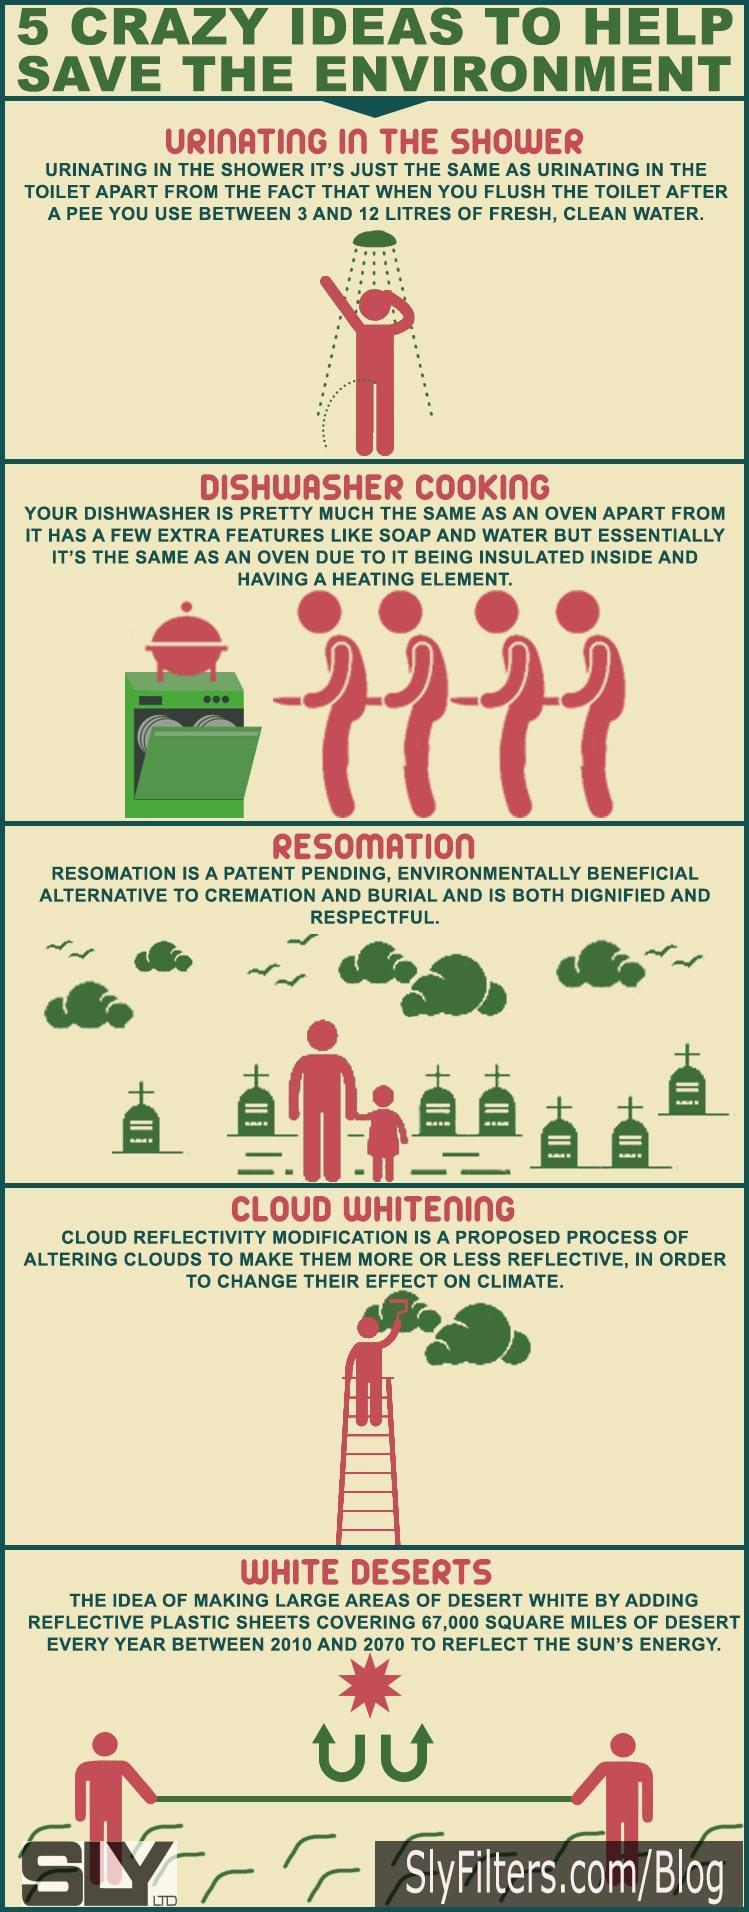how may years in total is planned for white deserts
Answer the question with a short phrase. 60 What features in a dishwasher are not available in the oven soap and water what is the person doing in the shower as per image urinating how many gravestones are visible 7 what is the painter painting cloud 